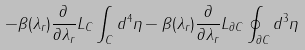<formula> <loc_0><loc_0><loc_500><loc_500>- \beta ( \lambda _ { r } ) \frac { \partial } { \partial \lambda _ { r } } L _ { C } \int _ { C } d ^ { 4 } \eta - \beta ( \lambda _ { r } ) \frac { \partial } { \partial \lambda _ { r } } L _ { \partial C } \oint _ { \partial C } d ^ { 3 } \eta</formula> 